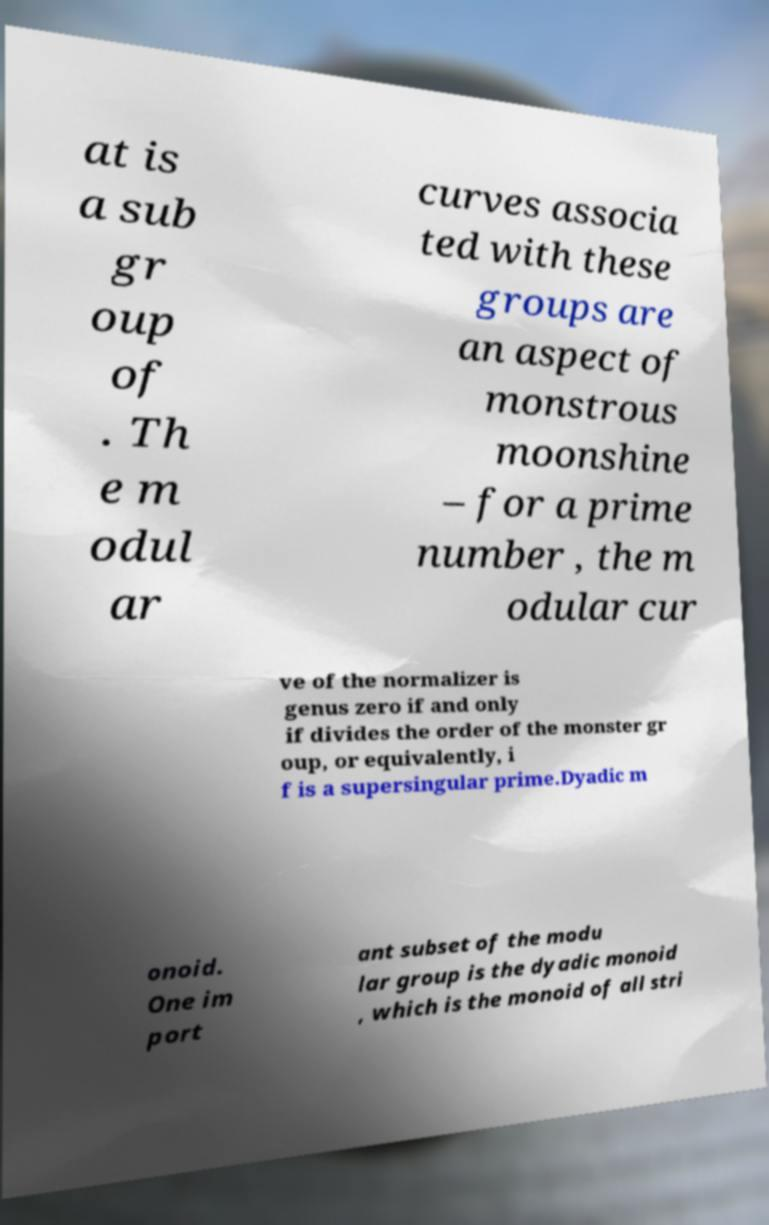Could you assist in decoding the text presented in this image and type it out clearly? at is a sub gr oup of . Th e m odul ar curves associa ted with these groups are an aspect of monstrous moonshine – for a prime number , the m odular cur ve of the normalizer is genus zero if and only if divides the order of the monster gr oup, or equivalently, i f is a supersingular prime.Dyadic m onoid. One im port ant subset of the modu lar group is the dyadic monoid , which is the monoid of all stri 